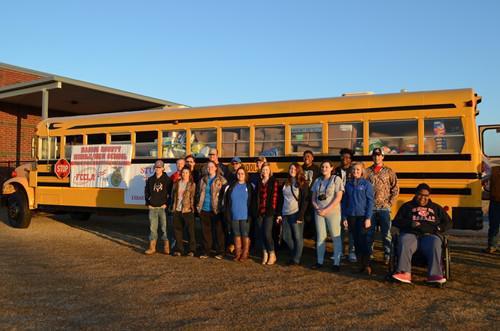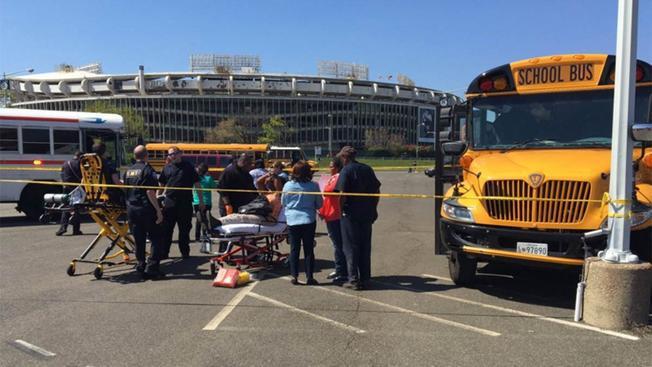The first image is the image on the left, the second image is the image on the right. Analyze the images presented: Is the assertion "An emergency is being dealt with right next to a school bus in one of the pictures." valid? Answer yes or no. Yes. The first image is the image on the left, the second image is the image on the right. Analyze the images presented: Is the assertion "The image on the right shows the back end of at least one bus." valid? Answer yes or no. No. 